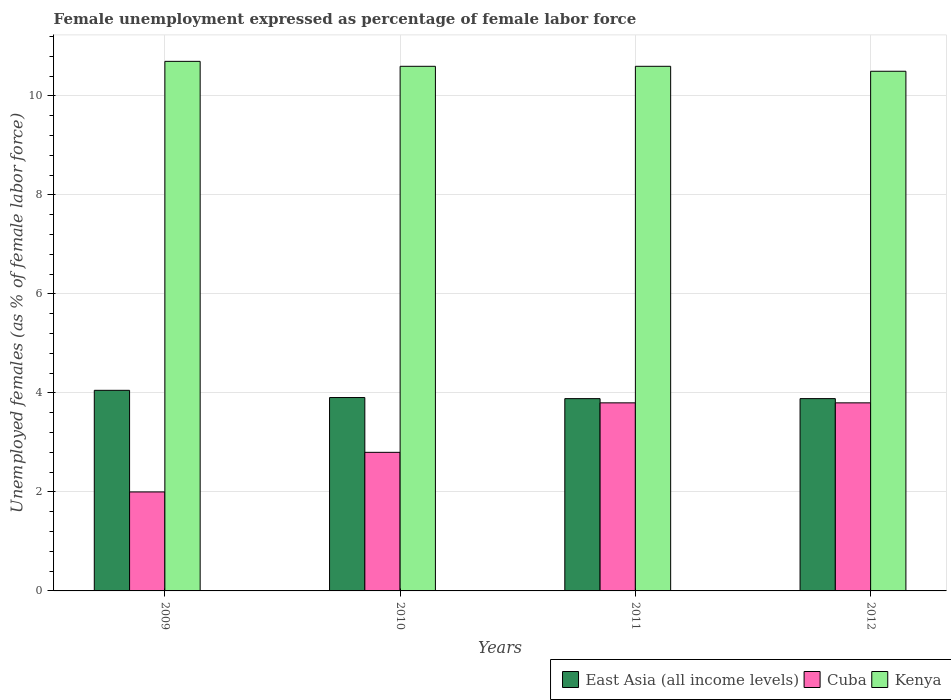How many different coloured bars are there?
Ensure brevity in your answer.  3. How many groups of bars are there?
Make the answer very short. 4. Are the number of bars per tick equal to the number of legend labels?
Keep it short and to the point. Yes. How many bars are there on the 3rd tick from the left?
Offer a very short reply. 3. What is the label of the 3rd group of bars from the left?
Your answer should be compact. 2011. In how many cases, is the number of bars for a given year not equal to the number of legend labels?
Offer a terse response. 0. What is the unemployment in females in in Kenya in 2011?
Your answer should be compact. 10.6. Across all years, what is the maximum unemployment in females in in East Asia (all income levels)?
Make the answer very short. 4.05. In which year was the unemployment in females in in East Asia (all income levels) minimum?
Provide a succinct answer. 2011. What is the total unemployment in females in in Cuba in the graph?
Offer a terse response. 12.4. What is the difference between the unemployment in females in in East Asia (all income levels) in 2009 and that in 2012?
Offer a very short reply. 0.17. What is the difference between the unemployment in females in in East Asia (all income levels) in 2011 and the unemployment in females in in Kenya in 2009?
Offer a very short reply. -6.81. What is the average unemployment in females in in Cuba per year?
Your answer should be very brief. 3.1. In the year 2009, what is the difference between the unemployment in females in in East Asia (all income levels) and unemployment in females in in Kenya?
Offer a terse response. -6.65. In how many years, is the unemployment in females in in East Asia (all income levels) greater than 7.2 %?
Keep it short and to the point. 0. What is the difference between the highest and the second highest unemployment in females in in Kenya?
Provide a succinct answer. 0.1. What is the difference between the highest and the lowest unemployment in females in in Kenya?
Provide a short and direct response. 0.2. What does the 3rd bar from the left in 2012 represents?
Your answer should be compact. Kenya. What does the 1st bar from the right in 2011 represents?
Give a very brief answer. Kenya. Is it the case that in every year, the sum of the unemployment in females in in Kenya and unemployment in females in in East Asia (all income levels) is greater than the unemployment in females in in Cuba?
Offer a very short reply. Yes. Are all the bars in the graph horizontal?
Keep it short and to the point. No. What is the difference between two consecutive major ticks on the Y-axis?
Keep it short and to the point. 2. Are the values on the major ticks of Y-axis written in scientific E-notation?
Offer a terse response. No. How are the legend labels stacked?
Your answer should be very brief. Horizontal. What is the title of the graph?
Your response must be concise. Female unemployment expressed as percentage of female labor force. What is the label or title of the X-axis?
Ensure brevity in your answer.  Years. What is the label or title of the Y-axis?
Your response must be concise. Unemployed females (as % of female labor force). What is the Unemployed females (as % of female labor force) in East Asia (all income levels) in 2009?
Offer a very short reply. 4.05. What is the Unemployed females (as % of female labor force) of Kenya in 2009?
Offer a very short reply. 10.7. What is the Unemployed females (as % of female labor force) in East Asia (all income levels) in 2010?
Ensure brevity in your answer.  3.91. What is the Unemployed females (as % of female labor force) in Cuba in 2010?
Your response must be concise. 2.8. What is the Unemployed females (as % of female labor force) in Kenya in 2010?
Make the answer very short. 10.6. What is the Unemployed females (as % of female labor force) in East Asia (all income levels) in 2011?
Your answer should be compact. 3.89. What is the Unemployed females (as % of female labor force) in Cuba in 2011?
Give a very brief answer. 3.8. What is the Unemployed females (as % of female labor force) in Kenya in 2011?
Make the answer very short. 10.6. What is the Unemployed females (as % of female labor force) of East Asia (all income levels) in 2012?
Provide a succinct answer. 3.89. What is the Unemployed females (as % of female labor force) in Cuba in 2012?
Provide a short and direct response. 3.8. What is the Unemployed females (as % of female labor force) of Kenya in 2012?
Ensure brevity in your answer.  10.5. Across all years, what is the maximum Unemployed females (as % of female labor force) in East Asia (all income levels)?
Your answer should be very brief. 4.05. Across all years, what is the maximum Unemployed females (as % of female labor force) in Cuba?
Keep it short and to the point. 3.8. Across all years, what is the maximum Unemployed females (as % of female labor force) in Kenya?
Offer a terse response. 10.7. Across all years, what is the minimum Unemployed females (as % of female labor force) in East Asia (all income levels)?
Your response must be concise. 3.89. What is the total Unemployed females (as % of female labor force) of East Asia (all income levels) in the graph?
Keep it short and to the point. 15.73. What is the total Unemployed females (as % of female labor force) in Kenya in the graph?
Your answer should be very brief. 42.4. What is the difference between the Unemployed females (as % of female labor force) in East Asia (all income levels) in 2009 and that in 2010?
Offer a terse response. 0.15. What is the difference between the Unemployed females (as % of female labor force) in Cuba in 2009 and that in 2010?
Keep it short and to the point. -0.8. What is the difference between the Unemployed females (as % of female labor force) of Kenya in 2009 and that in 2010?
Your response must be concise. 0.1. What is the difference between the Unemployed females (as % of female labor force) in East Asia (all income levels) in 2009 and that in 2011?
Give a very brief answer. 0.17. What is the difference between the Unemployed females (as % of female labor force) in Cuba in 2009 and that in 2011?
Offer a very short reply. -1.8. What is the difference between the Unemployed females (as % of female labor force) of East Asia (all income levels) in 2009 and that in 2012?
Keep it short and to the point. 0.17. What is the difference between the Unemployed females (as % of female labor force) in Cuba in 2009 and that in 2012?
Your answer should be compact. -1.8. What is the difference between the Unemployed females (as % of female labor force) of Kenya in 2009 and that in 2012?
Your answer should be compact. 0.2. What is the difference between the Unemployed females (as % of female labor force) in East Asia (all income levels) in 2010 and that in 2011?
Your answer should be compact. 0.02. What is the difference between the Unemployed females (as % of female labor force) in Cuba in 2010 and that in 2011?
Keep it short and to the point. -1. What is the difference between the Unemployed females (as % of female labor force) of Kenya in 2010 and that in 2011?
Make the answer very short. 0. What is the difference between the Unemployed females (as % of female labor force) in East Asia (all income levels) in 2010 and that in 2012?
Provide a succinct answer. 0.02. What is the difference between the Unemployed females (as % of female labor force) in East Asia (all income levels) in 2011 and that in 2012?
Provide a succinct answer. -0. What is the difference between the Unemployed females (as % of female labor force) of Cuba in 2011 and that in 2012?
Ensure brevity in your answer.  0. What is the difference between the Unemployed females (as % of female labor force) in East Asia (all income levels) in 2009 and the Unemployed females (as % of female labor force) in Cuba in 2010?
Offer a terse response. 1.25. What is the difference between the Unemployed females (as % of female labor force) of East Asia (all income levels) in 2009 and the Unemployed females (as % of female labor force) of Kenya in 2010?
Your answer should be very brief. -6.55. What is the difference between the Unemployed females (as % of female labor force) of Cuba in 2009 and the Unemployed females (as % of female labor force) of Kenya in 2010?
Make the answer very short. -8.6. What is the difference between the Unemployed females (as % of female labor force) of East Asia (all income levels) in 2009 and the Unemployed females (as % of female labor force) of Cuba in 2011?
Make the answer very short. 0.25. What is the difference between the Unemployed females (as % of female labor force) of East Asia (all income levels) in 2009 and the Unemployed females (as % of female labor force) of Kenya in 2011?
Your response must be concise. -6.55. What is the difference between the Unemployed females (as % of female labor force) in Cuba in 2009 and the Unemployed females (as % of female labor force) in Kenya in 2011?
Make the answer very short. -8.6. What is the difference between the Unemployed females (as % of female labor force) in East Asia (all income levels) in 2009 and the Unemployed females (as % of female labor force) in Cuba in 2012?
Give a very brief answer. 0.25. What is the difference between the Unemployed females (as % of female labor force) of East Asia (all income levels) in 2009 and the Unemployed females (as % of female labor force) of Kenya in 2012?
Provide a succinct answer. -6.45. What is the difference between the Unemployed females (as % of female labor force) of Cuba in 2009 and the Unemployed females (as % of female labor force) of Kenya in 2012?
Your answer should be compact. -8.5. What is the difference between the Unemployed females (as % of female labor force) in East Asia (all income levels) in 2010 and the Unemployed females (as % of female labor force) in Cuba in 2011?
Ensure brevity in your answer.  0.11. What is the difference between the Unemployed females (as % of female labor force) in East Asia (all income levels) in 2010 and the Unemployed females (as % of female labor force) in Kenya in 2011?
Provide a short and direct response. -6.69. What is the difference between the Unemployed females (as % of female labor force) of Cuba in 2010 and the Unemployed females (as % of female labor force) of Kenya in 2011?
Offer a terse response. -7.8. What is the difference between the Unemployed females (as % of female labor force) of East Asia (all income levels) in 2010 and the Unemployed females (as % of female labor force) of Cuba in 2012?
Provide a short and direct response. 0.11. What is the difference between the Unemployed females (as % of female labor force) of East Asia (all income levels) in 2010 and the Unemployed females (as % of female labor force) of Kenya in 2012?
Your answer should be very brief. -6.59. What is the difference between the Unemployed females (as % of female labor force) in Cuba in 2010 and the Unemployed females (as % of female labor force) in Kenya in 2012?
Offer a very short reply. -7.7. What is the difference between the Unemployed females (as % of female labor force) in East Asia (all income levels) in 2011 and the Unemployed females (as % of female labor force) in Cuba in 2012?
Offer a terse response. 0.09. What is the difference between the Unemployed females (as % of female labor force) in East Asia (all income levels) in 2011 and the Unemployed females (as % of female labor force) in Kenya in 2012?
Provide a succinct answer. -6.61. What is the average Unemployed females (as % of female labor force) of East Asia (all income levels) per year?
Ensure brevity in your answer.  3.93. What is the average Unemployed females (as % of female labor force) in Kenya per year?
Offer a very short reply. 10.6. In the year 2009, what is the difference between the Unemployed females (as % of female labor force) of East Asia (all income levels) and Unemployed females (as % of female labor force) of Cuba?
Make the answer very short. 2.05. In the year 2009, what is the difference between the Unemployed females (as % of female labor force) of East Asia (all income levels) and Unemployed females (as % of female labor force) of Kenya?
Provide a short and direct response. -6.65. In the year 2009, what is the difference between the Unemployed females (as % of female labor force) in Cuba and Unemployed females (as % of female labor force) in Kenya?
Ensure brevity in your answer.  -8.7. In the year 2010, what is the difference between the Unemployed females (as % of female labor force) of East Asia (all income levels) and Unemployed females (as % of female labor force) of Cuba?
Provide a short and direct response. 1.11. In the year 2010, what is the difference between the Unemployed females (as % of female labor force) in East Asia (all income levels) and Unemployed females (as % of female labor force) in Kenya?
Your response must be concise. -6.69. In the year 2010, what is the difference between the Unemployed females (as % of female labor force) in Cuba and Unemployed females (as % of female labor force) in Kenya?
Offer a very short reply. -7.8. In the year 2011, what is the difference between the Unemployed females (as % of female labor force) in East Asia (all income levels) and Unemployed females (as % of female labor force) in Cuba?
Keep it short and to the point. 0.09. In the year 2011, what is the difference between the Unemployed females (as % of female labor force) of East Asia (all income levels) and Unemployed females (as % of female labor force) of Kenya?
Ensure brevity in your answer.  -6.71. In the year 2012, what is the difference between the Unemployed females (as % of female labor force) in East Asia (all income levels) and Unemployed females (as % of female labor force) in Cuba?
Offer a very short reply. 0.09. In the year 2012, what is the difference between the Unemployed females (as % of female labor force) of East Asia (all income levels) and Unemployed females (as % of female labor force) of Kenya?
Provide a succinct answer. -6.61. What is the ratio of the Unemployed females (as % of female labor force) of East Asia (all income levels) in 2009 to that in 2010?
Your answer should be very brief. 1.04. What is the ratio of the Unemployed females (as % of female labor force) in Kenya in 2009 to that in 2010?
Offer a terse response. 1.01. What is the ratio of the Unemployed females (as % of female labor force) of East Asia (all income levels) in 2009 to that in 2011?
Make the answer very short. 1.04. What is the ratio of the Unemployed females (as % of female labor force) of Cuba in 2009 to that in 2011?
Your response must be concise. 0.53. What is the ratio of the Unemployed females (as % of female labor force) of Kenya in 2009 to that in 2011?
Provide a short and direct response. 1.01. What is the ratio of the Unemployed females (as % of female labor force) of East Asia (all income levels) in 2009 to that in 2012?
Provide a short and direct response. 1.04. What is the ratio of the Unemployed females (as % of female labor force) in Cuba in 2009 to that in 2012?
Make the answer very short. 0.53. What is the ratio of the Unemployed females (as % of female labor force) in Kenya in 2009 to that in 2012?
Your answer should be very brief. 1.02. What is the ratio of the Unemployed females (as % of female labor force) in East Asia (all income levels) in 2010 to that in 2011?
Offer a very short reply. 1.01. What is the ratio of the Unemployed females (as % of female labor force) of Cuba in 2010 to that in 2011?
Ensure brevity in your answer.  0.74. What is the ratio of the Unemployed females (as % of female labor force) in Kenya in 2010 to that in 2011?
Ensure brevity in your answer.  1. What is the ratio of the Unemployed females (as % of female labor force) of East Asia (all income levels) in 2010 to that in 2012?
Your response must be concise. 1.01. What is the ratio of the Unemployed females (as % of female labor force) in Cuba in 2010 to that in 2012?
Offer a very short reply. 0.74. What is the ratio of the Unemployed females (as % of female labor force) of Kenya in 2010 to that in 2012?
Offer a very short reply. 1.01. What is the ratio of the Unemployed females (as % of female labor force) of Cuba in 2011 to that in 2012?
Your answer should be compact. 1. What is the ratio of the Unemployed females (as % of female labor force) of Kenya in 2011 to that in 2012?
Give a very brief answer. 1.01. What is the difference between the highest and the second highest Unemployed females (as % of female labor force) of East Asia (all income levels)?
Give a very brief answer. 0.15. What is the difference between the highest and the second highest Unemployed females (as % of female labor force) of Cuba?
Provide a short and direct response. 0. What is the difference between the highest and the lowest Unemployed females (as % of female labor force) in East Asia (all income levels)?
Provide a succinct answer. 0.17. What is the difference between the highest and the lowest Unemployed females (as % of female labor force) in Kenya?
Ensure brevity in your answer.  0.2. 